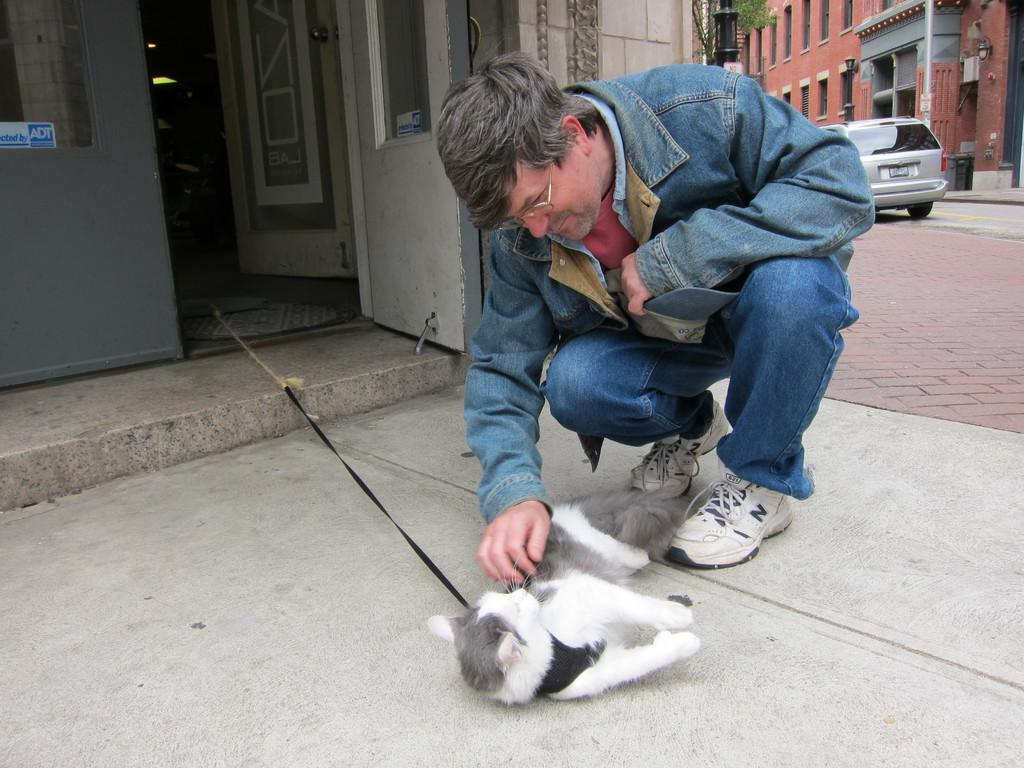Who is present in the image? There is a person in the image. What is the person wearing? The person is wearing a jacket. What is the person doing in the image? The person is crouching down on the floor. What type of animal is in the image? There is a pussy cat in the image. How is the pussy cat being controlled or restrained? The pussy cat has a leash. What can be seen in the background of the image? There is a car and a building in the background of the image. What type of bear can be seen in the image? There is no bear present in the image. The image features a person, a pussy cat with a leash, and a car and building in the background. 